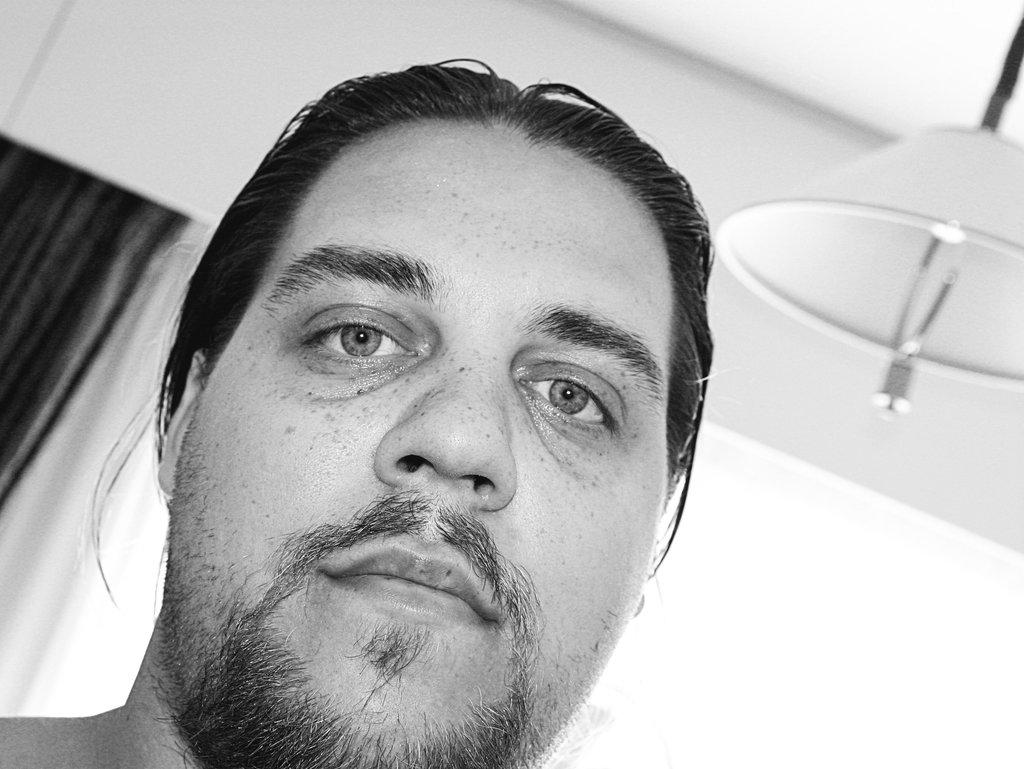What is the color scheme of the image? The image is black and white. What can be seen in the background of the image? There is a wall and cloth in the background of the image. Whose face is visible in the image? A person's face is visible in the image. What is located on the right side of the image? There is an object on the right side of the image. What type of church can be seen in the image? There is no church present in the image. What color is the governor's tie in the image? There is no governor or tie present in the image. 